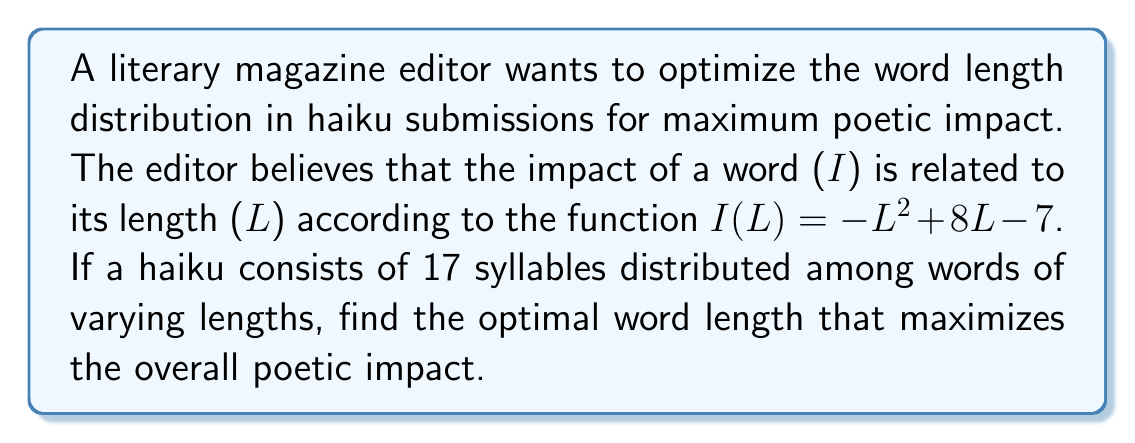Solve this math problem. To find the optimal word length for maximum poetic impact, we need to find the maximum of the function $I(L) = -L^2 + 8L - 7$.

1. First, let's find the derivative of $I(L)$ with respect to $L$:
   $$\frac{dI}{dL} = -2L + 8$$

2. To find the maximum, we set the derivative equal to zero and solve for $L$:
   $$-2L + 8 = 0$$
   $$-2L = -8$$
   $$L = 4$$

3. To confirm this is a maximum (not a minimum), we can check the second derivative:
   $$\frac{d^2I}{dL^2} = -2$$
   Since the second derivative is negative, we confirm that $L = 4$ gives a maximum.

4. We can verify this by evaluating $I(L)$ at $L = 3$, $L = 4$, and $L = 5$:
   $$I(3) = -(3)^2 + 8(3) - 7 = -9 + 24 - 7 = 8$$
   $$I(4) = -(4)^2 + 8(4) - 7 = -16 + 32 - 7 = 9$$
   $$I(5) = -(5)^2 + 8(5) - 7 = -25 + 40 - 7 = 8$$

Therefore, the optimal word length for maximum poetic impact is 4 syllables.
Answer: The optimal word length for maximum poetic impact is 4 syllables. 